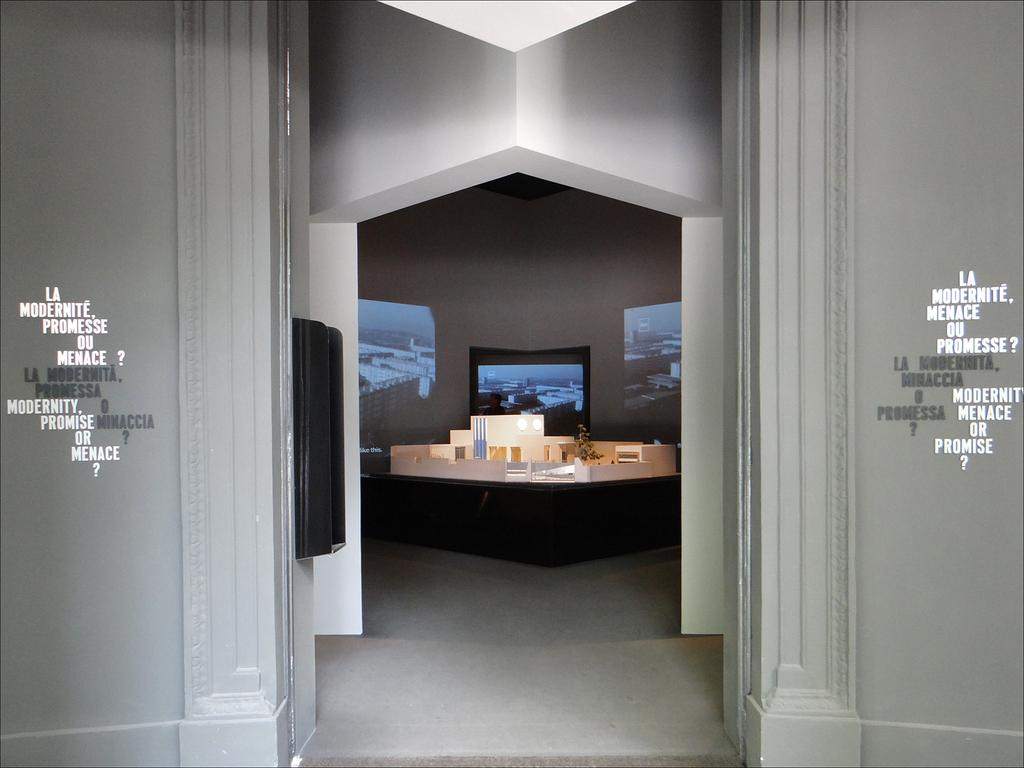What type of structure can be seen in the image? There are walls in the image, which suggests a room or enclosed space. Is there any text visible in the image? Yes, there is some text visible in the image. What type of electronic devices are present in the image? There are screens in the image, which could be monitors or televisions. What type of furniture is present in the image? There is a desk in the image, which is commonly used for work or study. What other objects can be seen in the image? There are various objects in the image, but their specific nature is not mentioned in the provided facts. What is the black box in the image used for? The purpose of the black box in the image is not mentioned in the provided facts. What can be seen at the bottom of the image? The floor is visible at the bottom of the image. How many kittens are playing on the desk in the image? There are no kittens present in the image. What type of battle is taking place in the image? There is no battle depicted in the image. Are there any ants visible on the floor in the image? There is no mention of ants in the provided facts. 